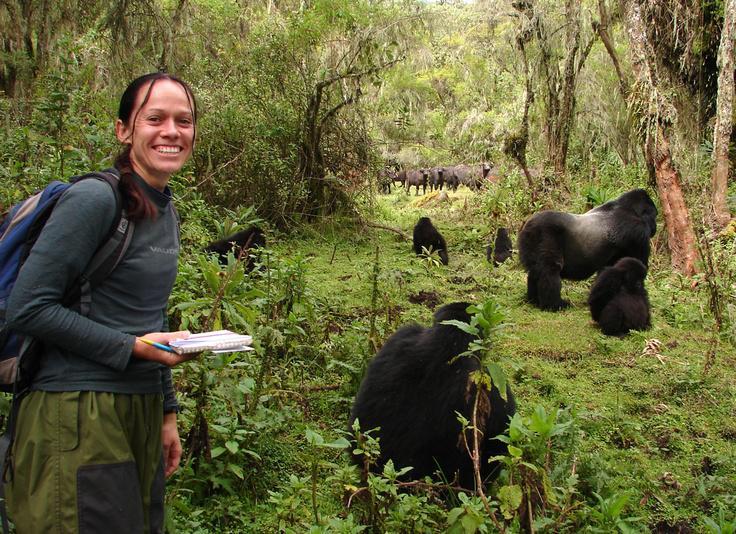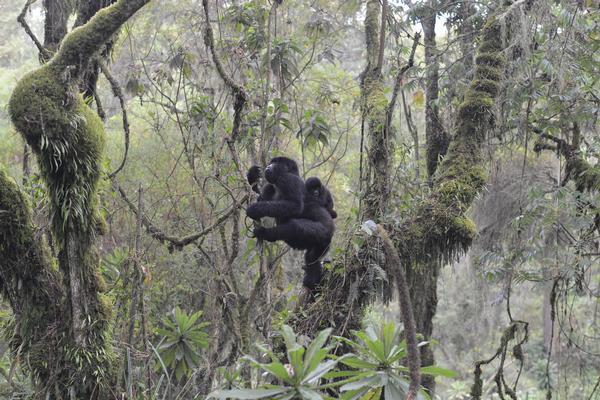The first image is the image on the left, the second image is the image on the right. Considering the images on both sides, is "A camera-facing person is holding a notebook and standing near a group of gorillas in a forest." valid? Answer yes or no. Yes. The first image is the image on the left, the second image is the image on the right. Considering the images on both sides, is "The right image contains no more than one gorilla." valid? Answer yes or no. No. 